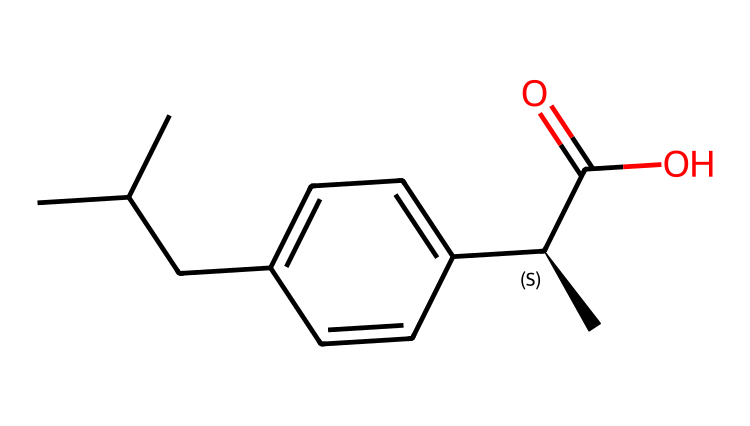What is the molecular formula of ibuprofen? To determine the molecular formula, count the number of each type of atom represented in the SMILES. In this case, there are 13 carbon (C) atoms, 18 hydrogen (H) atoms, and 2 oxygen (O) atoms, leading to the formula C13H18O2.
Answer: C13H18O2 How many chiral centers are present in ibuprofen? A chiral center is typically a carbon atom bonded to four different groups. In the provided SMILES, there is one carbon atom indicated by the symbol '@' (C@H) which signifies a chiral center. Thus, there is one chiral center in ibuprofen.
Answer: 1 What functional group is present in ibuprofen? Identify the distinguishing groups in the structure. The presence of a carboxylic acid group (-COOH) can be recognized as a functional group in ibuprofen. This is indicated by the C(=O)O part of the SMILES.
Answer: carboxylic acid Which part of ibuprofen determines its chiral nature? The chiral nature is determined by the carbon atom that is chiral, which is indicated by the '@' symbol. This specific carbon is attached to four different substituents making it the chiral center of the molecule.
Answer: chiral center What type of compound is ibuprofen classified as? To classify ibuprofen, we note its therapeutic use and structure. It is an anti-inflammatory drug, belonging to the non-steroidal anti-inflammatory drugs (NSAIDs) class. So, ibuprofen can be classified based on its activity and structure.
Answer: NSAID What is the total number of oxygen atoms in ibuprofen? By analyzing the SMILES structure, we identify two oxygen atoms (O) represented in the carboxylic acid group and within the carbonyl (C=O). Therefore, the total count of oxygen atoms is two.
Answer: 2 